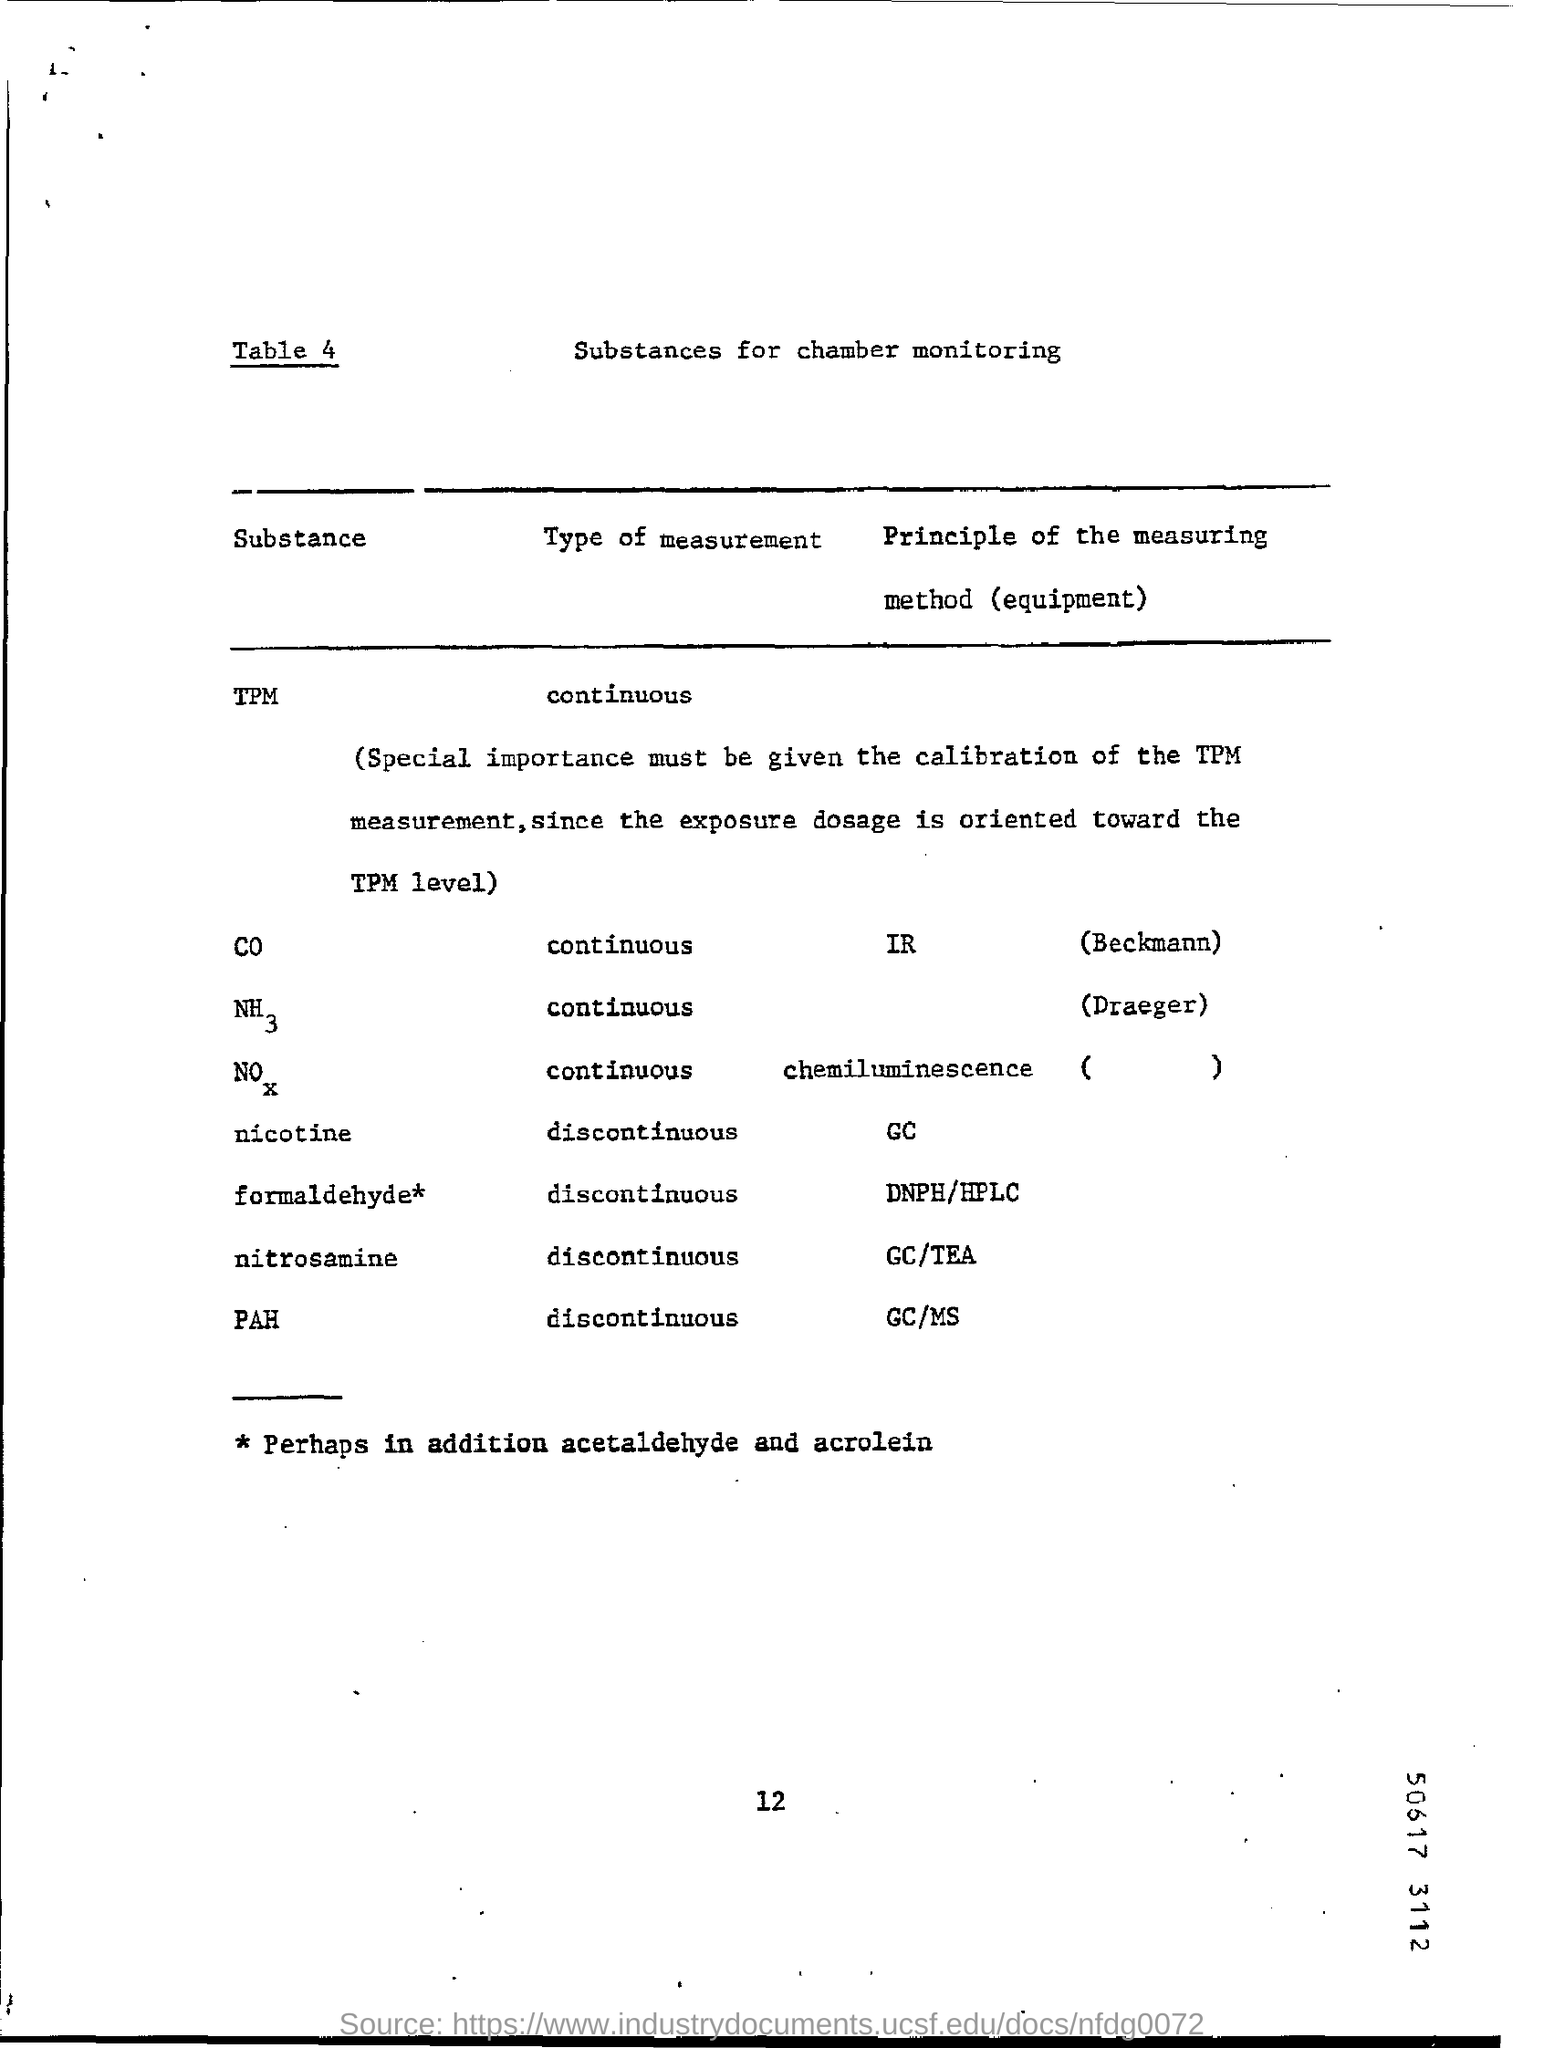What is the type of measurement for tpm?
Your answer should be very brief. Continuous. What is the principle of measuring method for pah?
Give a very brief answer. GC/MS. 